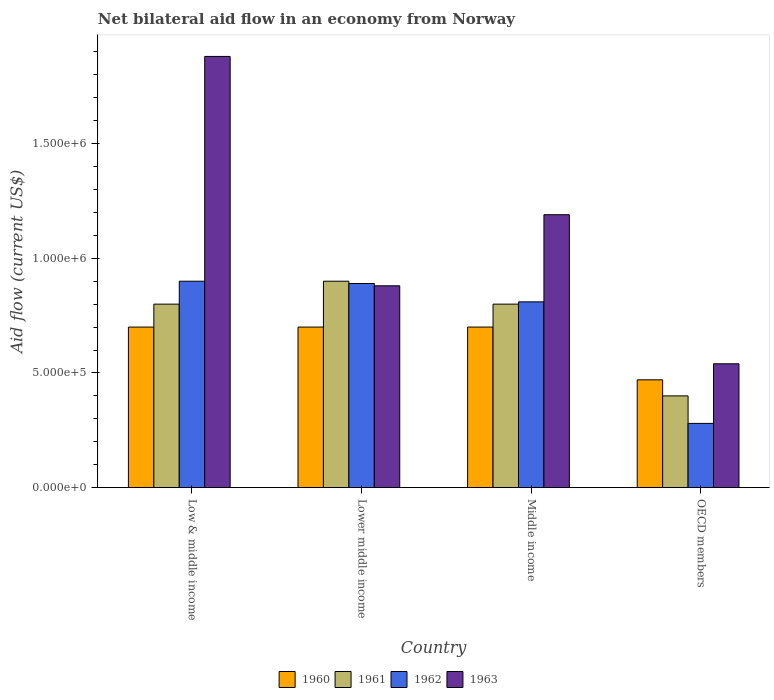How many different coloured bars are there?
Ensure brevity in your answer.  4. What is the net bilateral aid flow in 1960 in OECD members?
Provide a short and direct response. 4.70e+05. Across all countries, what is the maximum net bilateral aid flow in 1961?
Your answer should be compact. 9.00e+05. In which country was the net bilateral aid flow in 1960 minimum?
Offer a very short reply. OECD members. What is the total net bilateral aid flow in 1963 in the graph?
Offer a very short reply. 4.49e+06. What is the difference between the net bilateral aid flow in 1962 in OECD members and the net bilateral aid flow in 1963 in Lower middle income?
Provide a succinct answer. -6.00e+05. What is the average net bilateral aid flow in 1961 per country?
Your answer should be very brief. 7.25e+05. What is the difference between the net bilateral aid flow of/in 1963 and net bilateral aid flow of/in 1961 in Low & middle income?
Your answer should be compact. 1.08e+06. What is the ratio of the net bilateral aid flow in 1962 in Low & middle income to that in OECD members?
Keep it short and to the point. 3.21. What is the difference between the highest and the second highest net bilateral aid flow in 1963?
Give a very brief answer. 6.90e+05. What is the difference between the highest and the lowest net bilateral aid flow in 1960?
Your answer should be compact. 2.30e+05. In how many countries, is the net bilateral aid flow in 1961 greater than the average net bilateral aid flow in 1961 taken over all countries?
Provide a succinct answer. 3. Is it the case that in every country, the sum of the net bilateral aid flow in 1962 and net bilateral aid flow in 1961 is greater than the sum of net bilateral aid flow in 1960 and net bilateral aid flow in 1963?
Offer a terse response. No. Is it the case that in every country, the sum of the net bilateral aid flow in 1963 and net bilateral aid flow in 1962 is greater than the net bilateral aid flow in 1960?
Make the answer very short. Yes. Where does the legend appear in the graph?
Provide a succinct answer. Bottom center. How many legend labels are there?
Offer a very short reply. 4. How are the legend labels stacked?
Your answer should be compact. Horizontal. What is the title of the graph?
Offer a very short reply. Net bilateral aid flow in an economy from Norway. Does "1982" appear as one of the legend labels in the graph?
Your answer should be very brief. No. What is the label or title of the Y-axis?
Provide a short and direct response. Aid flow (current US$). What is the Aid flow (current US$) in 1960 in Low & middle income?
Make the answer very short. 7.00e+05. What is the Aid flow (current US$) of 1963 in Low & middle income?
Your answer should be very brief. 1.88e+06. What is the Aid flow (current US$) of 1960 in Lower middle income?
Provide a short and direct response. 7.00e+05. What is the Aid flow (current US$) of 1962 in Lower middle income?
Offer a terse response. 8.90e+05. What is the Aid flow (current US$) of 1963 in Lower middle income?
Offer a terse response. 8.80e+05. What is the Aid flow (current US$) in 1962 in Middle income?
Keep it short and to the point. 8.10e+05. What is the Aid flow (current US$) of 1963 in Middle income?
Offer a terse response. 1.19e+06. What is the Aid flow (current US$) in 1961 in OECD members?
Offer a terse response. 4.00e+05. What is the Aid flow (current US$) in 1963 in OECD members?
Keep it short and to the point. 5.40e+05. Across all countries, what is the maximum Aid flow (current US$) of 1962?
Your answer should be compact. 9.00e+05. Across all countries, what is the maximum Aid flow (current US$) of 1963?
Make the answer very short. 1.88e+06. Across all countries, what is the minimum Aid flow (current US$) of 1963?
Offer a very short reply. 5.40e+05. What is the total Aid flow (current US$) of 1960 in the graph?
Offer a terse response. 2.57e+06. What is the total Aid flow (current US$) in 1961 in the graph?
Offer a terse response. 2.90e+06. What is the total Aid flow (current US$) in 1962 in the graph?
Offer a terse response. 2.88e+06. What is the total Aid flow (current US$) of 1963 in the graph?
Provide a short and direct response. 4.49e+06. What is the difference between the Aid flow (current US$) in 1960 in Low & middle income and that in Lower middle income?
Offer a very short reply. 0. What is the difference between the Aid flow (current US$) in 1963 in Low & middle income and that in Lower middle income?
Ensure brevity in your answer.  1.00e+06. What is the difference between the Aid flow (current US$) of 1960 in Low & middle income and that in Middle income?
Provide a succinct answer. 0. What is the difference between the Aid flow (current US$) in 1962 in Low & middle income and that in Middle income?
Provide a succinct answer. 9.00e+04. What is the difference between the Aid flow (current US$) of 1963 in Low & middle income and that in Middle income?
Your response must be concise. 6.90e+05. What is the difference between the Aid flow (current US$) of 1960 in Low & middle income and that in OECD members?
Provide a succinct answer. 2.30e+05. What is the difference between the Aid flow (current US$) in 1962 in Low & middle income and that in OECD members?
Your answer should be very brief. 6.20e+05. What is the difference between the Aid flow (current US$) of 1963 in Low & middle income and that in OECD members?
Provide a succinct answer. 1.34e+06. What is the difference between the Aid flow (current US$) in 1961 in Lower middle income and that in Middle income?
Make the answer very short. 1.00e+05. What is the difference between the Aid flow (current US$) of 1962 in Lower middle income and that in Middle income?
Provide a short and direct response. 8.00e+04. What is the difference between the Aid flow (current US$) of 1963 in Lower middle income and that in Middle income?
Offer a very short reply. -3.10e+05. What is the difference between the Aid flow (current US$) of 1961 in Lower middle income and that in OECD members?
Provide a succinct answer. 5.00e+05. What is the difference between the Aid flow (current US$) in 1963 in Lower middle income and that in OECD members?
Offer a terse response. 3.40e+05. What is the difference between the Aid flow (current US$) in 1960 in Middle income and that in OECD members?
Make the answer very short. 2.30e+05. What is the difference between the Aid flow (current US$) in 1962 in Middle income and that in OECD members?
Provide a short and direct response. 5.30e+05. What is the difference between the Aid flow (current US$) of 1963 in Middle income and that in OECD members?
Offer a very short reply. 6.50e+05. What is the difference between the Aid flow (current US$) in 1960 in Low & middle income and the Aid flow (current US$) in 1963 in Lower middle income?
Provide a succinct answer. -1.80e+05. What is the difference between the Aid flow (current US$) of 1961 in Low & middle income and the Aid flow (current US$) of 1962 in Lower middle income?
Give a very brief answer. -9.00e+04. What is the difference between the Aid flow (current US$) of 1962 in Low & middle income and the Aid flow (current US$) of 1963 in Lower middle income?
Ensure brevity in your answer.  2.00e+04. What is the difference between the Aid flow (current US$) in 1960 in Low & middle income and the Aid flow (current US$) in 1962 in Middle income?
Your response must be concise. -1.10e+05. What is the difference between the Aid flow (current US$) in 1960 in Low & middle income and the Aid flow (current US$) in 1963 in Middle income?
Provide a succinct answer. -4.90e+05. What is the difference between the Aid flow (current US$) of 1961 in Low & middle income and the Aid flow (current US$) of 1963 in Middle income?
Give a very brief answer. -3.90e+05. What is the difference between the Aid flow (current US$) in 1962 in Low & middle income and the Aid flow (current US$) in 1963 in Middle income?
Provide a succinct answer. -2.90e+05. What is the difference between the Aid flow (current US$) in 1960 in Low & middle income and the Aid flow (current US$) in 1961 in OECD members?
Provide a succinct answer. 3.00e+05. What is the difference between the Aid flow (current US$) of 1961 in Low & middle income and the Aid flow (current US$) of 1962 in OECD members?
Your response must be concise. 5.20e+05. What is the difference between the Aid flow (current US$) in 1960 in Lower middle income and the Aid flow (current US$) in 1962 in Middle income?
Provide a succinct answer. -1.10e+05. What is the difference between the Aid flow (current US$) of 1960 in Lower middle income and the Aid flow (current US$) of 1963 in Middle income?
Keep it short and to the point. -4.90e+05. What is the difference between the Aid flow (current US$) in 1961 in Lower middle income and the Aid flow (current US$) in 1962 in Middle income?
Your response must be concise. 9.00e+04. What is the difference between the Aid flow (current US$) in 1961 in Lower middle income and the Aid flow (current US$) in 1963 in Middle income?
Give a very brief answer. -2.90e+05. What is the difference between the Aid flow (current US$) of 1962 in Lower middle income and the Aid flow (current US$) of 1963 in Middle income?
Offer a terse response. -3.00e+05. What is the difference between the Aid flow (current US$) of 1960 in Lower middle income and the Aid flow (current US$) of 1961 in OECD members?
Provide a short and direct response. 3.00e+05. What is the difference between the Aid flow (current US$) of 1961 in Lower middle income and the Aid flow (current US$) of 1962 in OECD members?
Your answer should be very brief. 6.20e+05. What is the difference between the Aid flow (current US$) in 1962 in Lower middle income and the Aid flow (current US$) in 1963 in OECD members?
Give a very brief answer. 3.50e+05. What is the difference between the Aid flow (current US$) in 1960 in Middle income and the Aid flow (current US$) in 1961 in OECD members?
Provide a succinct answer. 3.00e+05. What is the difference between the Aid flow (current US$) of 1960 in Middle income and the Aid flow (current US$) of 1963 in OECD members?
Provide a succinct answer. 1.60e+05. What is the difference between the Aid flow (current US$) of 1961 in Middle income and the Aid flow (current US$) of 1962 in OECD members?
Give a very brief answer. 5.20e+05. What is the average Aid flow (current US$) in 1960 per country?
Your answer should be compact. 6.42e+05. What is the average Aid flow (current US$) in 1961 per country?
Your response must be concise. 7.25e+05. What is the average Aid flow (current US$) in 1962 per country?
Keep it short and to the point. 7.20e+05. What is the average Aid flow (current US$) of 1963 per country?
Keep it short and to the point. 1.12e+06. What is the difference between the Aid flow (current US$) in 1960 and Aid flow (current US$) in 1962 in Low & middle income?
Provide a short and direct response. -2.00e+05. What is the difference between the Aid flow (current US$) in 1960 and Aid flow (current US$) in 1963 in Low & middle income?
Provide a succinct answer. -1.18e+06. What is the difference between the Aid flow (current US$) in 1961 and Aid flow (current US$) in 1962 in Low & middle income?
Make the answer very short. -1.00e+05. What is the difference between the Aid flow (current US$) in 1961 and Aid flow (current US$) in 1963 in Low & middle income?
Keep it short and to the point. -1.08e+06. What is the difference between the Aid flow (current US$) of 1962 and Aid flow (current US$) of 1963 in Low & middle income?
Your answer should be very brief. -9.80e+05. What is the difference between the Aid flow (current US$) of 1960 and Aid flow (current US$) of 1962 in Lower middle income?
Keep it short and to the point. -1.90e+05. What is the difference between the Aid flow (current US$) in 1961 and Aid flow (current US$) in 1963 in Lower middle income?
Keep it short and to the point. 2.00e+04. What is the difference between the Aid flow (current US$) of 1960 and Aid flow (current US$) of 1961 in Middle income?
Your response must be concise. -1.00e+05. What is the difference between the Aid flow (current US$) of 1960 and Aid flow (current US$) of 1963 in Middle income?
Provide a short and direct response. -4.90e+05. What is the difference between the Aid flow (current US$) in 1961 and Aid flow (current US$) in 1963 in Middle income?
Provide a succinct answer. -3.90e+05. What is the difference between the Aid flow (current US$) of 1962 and Aid flow (current US$) of 1963 in Middle income?
Your response must be concise. -3.80e+05. What is the difference between the Aid flow (current US$) in 1960 and Aid flow (current US$) in 1962 in OECD members?
Ensure brevity in your answer.  1.90e+05. What is the difference between the Aid flow (current US$) in 1961 and Aid flow (current US$) in 1963 in OECD members?
Provide a short and direct response. -1.40e+05. What is the ratio of the Aid flow (current US$) of 1961 in Low & middle income to that in Lower middle income?
Make the answer very short. 0.89. What is the ratio of the Aid flow (current US$) in 1962 in Low & middle income to that in Lower middle income?
Your answer should be very brief. 1.01. What is the ratio of the Aid flow (current US$) in 1963 in Low & middle income to that in Lower middle income?
Make the answer very short. 2.14. What is the ratio of the Aid flow (current US$) of 1960 in Low & middle income to that in Middle income?
Provide a short and direct response. 1. What is the ratio of the Aid flow (current US$) of 1961 in Low & middle income to that in Middle income?
Ensure brevity in your answer.  1. What is the ratio of the Aid flow (current US$) of 1963 in Low & middle income to that in Middle income?
Your answer should be compact. 1.58. What is the ratio of the Aid flow (current US$) in 1960 in Low & middle income to that in OECD members?
Offer a terse response. 1.49. What is the ratio of the Aid flow (current US$) in 1961 in Low & middle income to that in OECD members?
Provide a short and direct response. 2. What is the ratio of the Aid flow (current US$) in 1962 in Low & middle income to that in OECD members?
Offer a very short reply. 3.21. What is the ratio of the Aid flow (current US$) of 1963 in Low & middle income to that in OECD members?
Give a very brief answer. 3.48. What is the ratio of the Aid flow (current US$) of 1960 in Lower middle income to that in Middle income?
Provide a succinct answer. 1. What is the ratio of the Aid flow (current US$) in 1962 in Lower middle income to that in Middle income?
Your answer should be very brief. 1.1. What is the ratio of the Aid flow (current US$) of 1963 in Lower middle income to that in Middle income?
Provide a succinct answer. 0.74. What is the ratio of the Aid flow (current US$) of 1960 in Lower middle income to that in OECD members?
Offer a terse response. 1.49. What is the ratio of the Aid flow (current US$) in 1961 in Lower middle income to that in OECD members?
Your answer should be very brief. 2.25. What is the ratio of the Aid flow (current US$) in 1962 in Lower middle income to that in OECD members?
Your response must be concise. 3.18. What is the ratio of the Aid flow (current US$) of 1963 in Lower middle income to that in OECD members?
Provide a short and direct response. 1.63. What is the ratio of the Aid flow (current US$) in 1960 in Middle income to that in OECD members?
Your answer should be very brief. 1.49. What is the ratio of the Aid flow (current US$) of 1961 in Middle income to that in OECD members?
Keep it short and to the point. 2. What is the ratio of the Aid flow (current US$) in 1962 in Middle income to that in OECD members?
Provide a short and direct response. 2.89. What is the ratio of the Aid flow (current US$) of 1963 in Middle income to that in OECD members?
Your response must be concise. 2.2. What is the difference between the highest and the second highest Aid flow (current US$) in 1963?
Your answer should be very brief. 6.90e+05. What is the difference between the highest and the lowest Aid flow (current US$) in 1961?
Offer a terse response. 5.00e+05. What is the difference between the highest and the lowest Aid flow (current US$) of 1962?
Provide a succinct answer. 6.20e+05. What is the difference between the highest and the lowest Aid flow (current US$) of 1963?
Provide a short and direct response. 1.34e+06. 